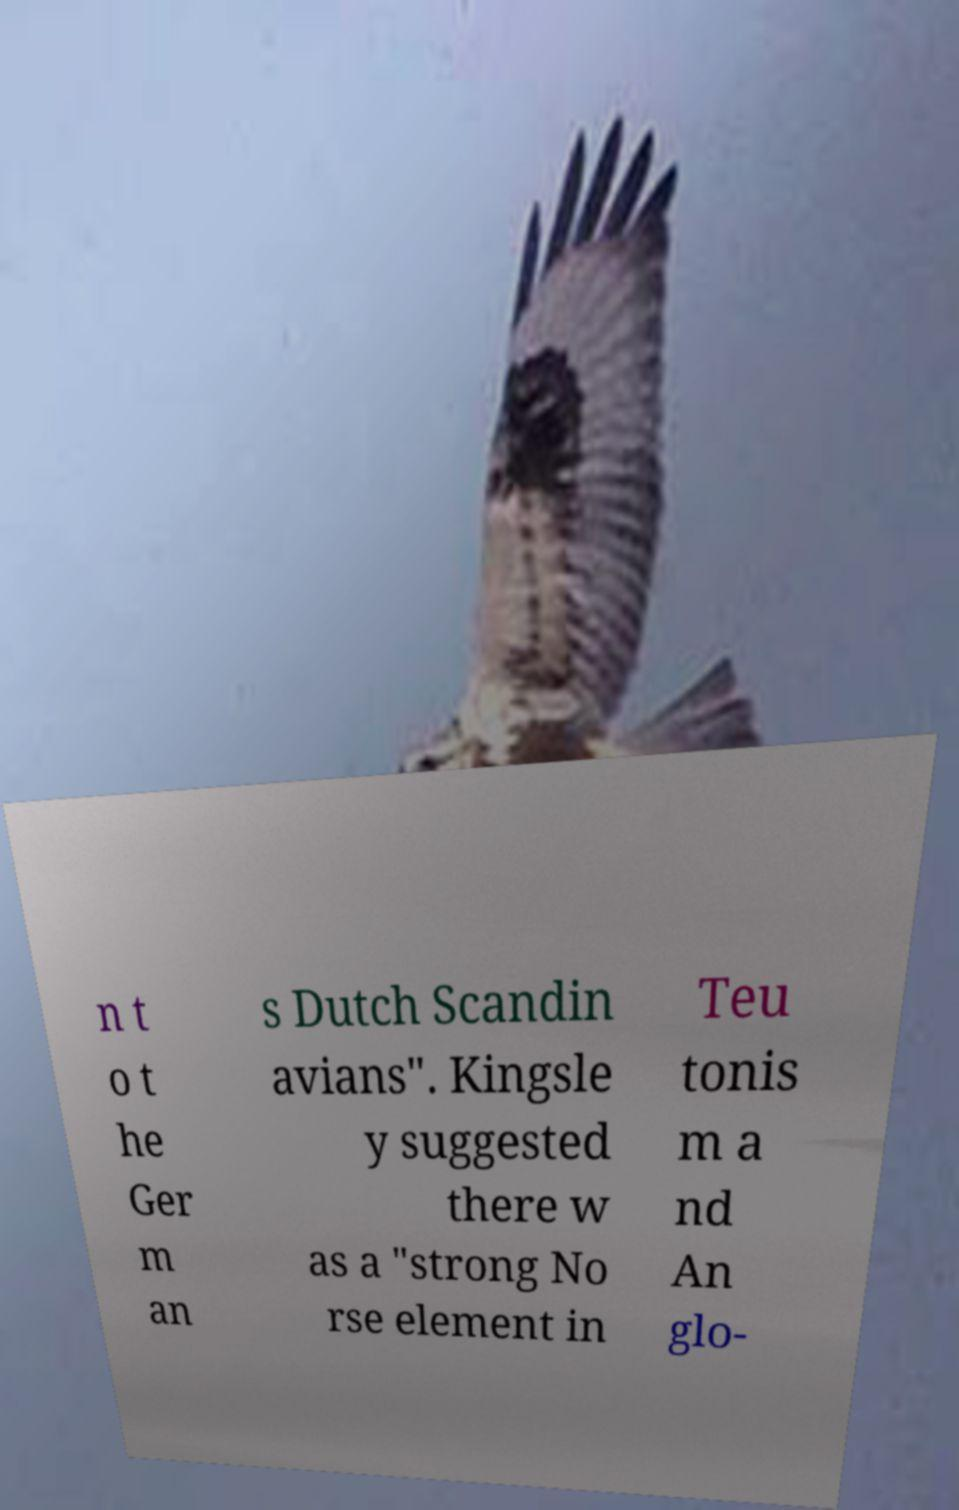Can you accurately transcribe the text from the provided image for me? n t o t he Ger m an s Dutch Scandin avians". Kingsle y suggested there w as a "strong No rse element in Teu tonis m a nd An glo- 